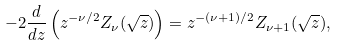Convert formula to latex. <formula><loc_0><loc_0><loc_500><loc_500>- 2 \frac { d } { d z } \left ( z ^ { - \nu / 2 } Z _ { \nu } ( \sqrt { z } ) \right ) = z ^ { - ( \nu + 1 ) / 2 } Z _ { \nu + 1 } ( \sqrt { z } ) ,</formula> 